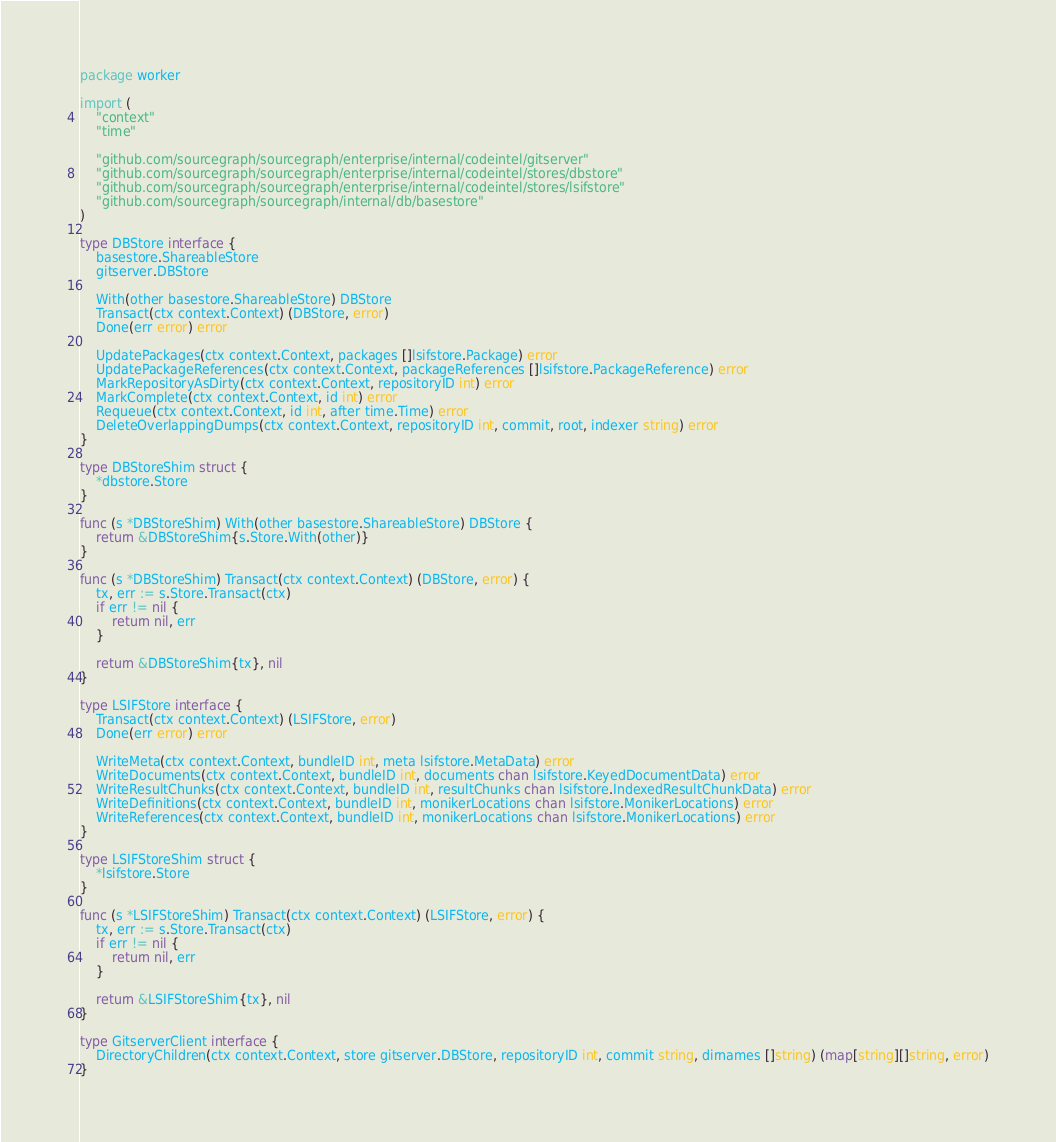Convert code to text. <code><loc_0><loc_0><loc_500><loc_500><_Go_>package worker

import (
	"context"
	"time"

	"github.com/sourcegraph/sourcegraph/enterprise/internal/codeintel/gitserver"
	"github.com/sourcegraph/sourcegraph/enterprise/internal/codeintel/stores/dbstore"
	"github.com/sourcegraph/sourcegraph/enterprise/internal/codeintel/stores/lsifstore"
	"github.com/sourcegraph/sourcegraph/internal/db/basestore"
)

type DBStore interface {
	basestore.ShareableStore
	gitserver.DBStore

	With(other basestore.ShareableStore) DBStore
	Transact(ctx context.Context) (DBStore, error)
	Done(err error) error

	UpdatePackages(ctx context.Context, packages []lsifstore.Package) error
	UpdatePackageReferences(ctx context.Context, packageReferences []lsifstore.PackageReference) error
	MarkRepositoryAsDirty(ctx context.Context, repositoryID int) error
	MarkComplete(ctx context.Context, id int) error
	Requeue(ctx context.Context, id int, after time.Time) error
	DeleteOverlappingDumps(ctx context.Context, repositoryID int, commit, root, indexer string) error
}

type DBStoreShim struct {
	*dbstore.Store
}

func (s *DBStoreShim) With(other basestore.ShareableStore) DBStore {
	return &DBStoreShim{s.Store.With(other)}
}

func (s *DBStoreShim) Transact(ctx context.Context) (DBStore, error) {
	tx, err := s.Store.Transact(ctx)
	if err != nil {
		return nil, err
	}

	return &DBStoreShim{tx}, nil
}

type LSIFStore interface {
	Transact(ctx context.Context) (LSIFStore, error)
	Done(err error) error

	WriteMeta(ctx context.Context, bundleID int, meta lsifstore.MetaData) error
	WriteDocuments(ctx context.Context, bundleID int, documents chan lsifstore.KeyedDocumentData) error
	WriteResultChunks(ctx context.Context, bundleID int, resultChunks chan lsifstore.IndexedResultChunkData) error
	WriteDefinitions(ctx context.Context, bundleID int, monikerLocations chan lsifstore.MonikerLocations) error
	WriteReferences(ctx context.Context, bundleID int, monikerLocations chan lsifstore.MonikerLocations) error
}

type LSIFStoreShim struct {
	*lsifstore.Store
}

func (s *LSIFStoreShim) Transact(ctx context.Context) (LSIFStore, error) {
	tx, err := s.Store.Transact(ctx)
	if err != nil {
		return nil, err
	}

	return &LSIFStoreShim{tx}, nil
}

type GitserverClient interface {
	DirectoryChildren(ctx context.Context, store gitserver.DBStore, repositoryID int, commit string, dirnames []string) (map[string][]string, error)
}
</code> 